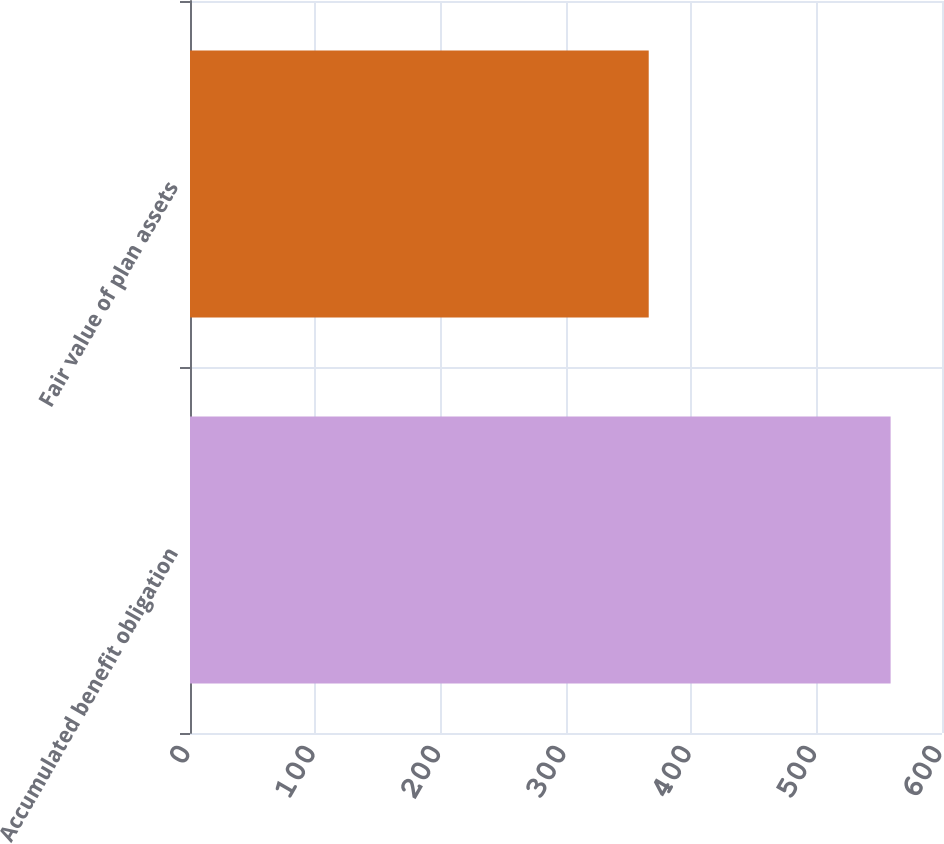Convert chart. <chart><loc_0><loc_0><loc_500><loc_500><bar_chart><fcel>Accumulated benefit obligation<fcel>Fair value of plan assets<nl><fcel>559<fcel>366<nl></chart> 